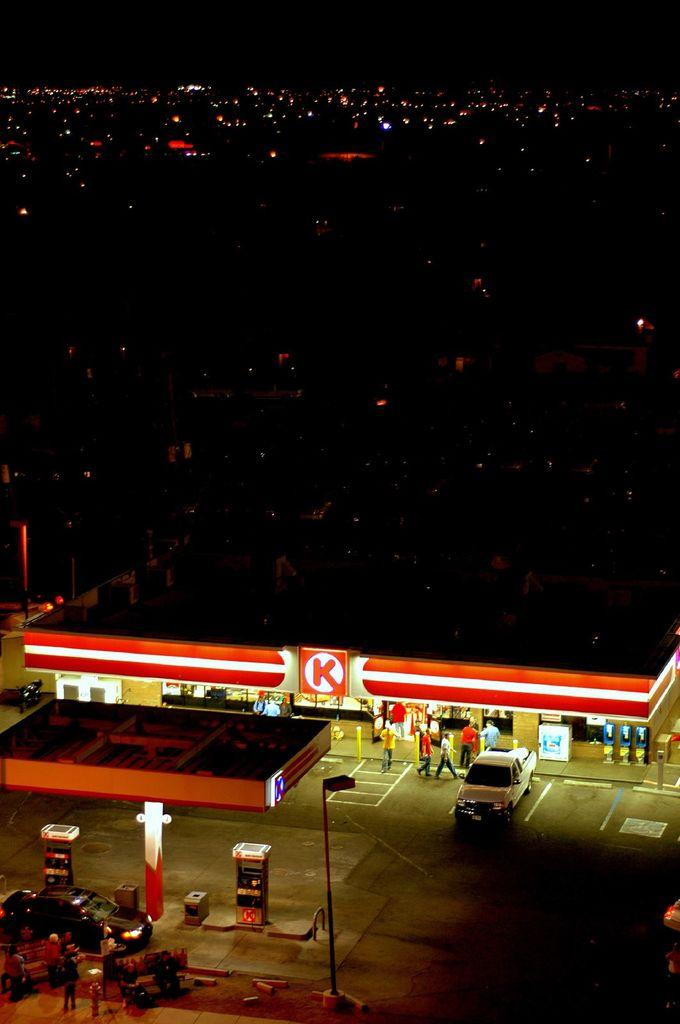Provide a one-sentence caption for the provided image. An aerial view of a store with a big K in red on the front. 